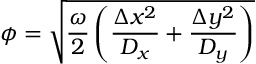<formula> <loc_0><loc_0><loc_500><loc_500>\phi = \sqrt { \frac { \omega } { 2 } \left ( \frac { \Delta x ^ { 2 } } { D _ { x } } + \frac { \Delta y ^ { 2 } } { D _ { y } } \right ) }</formula> 